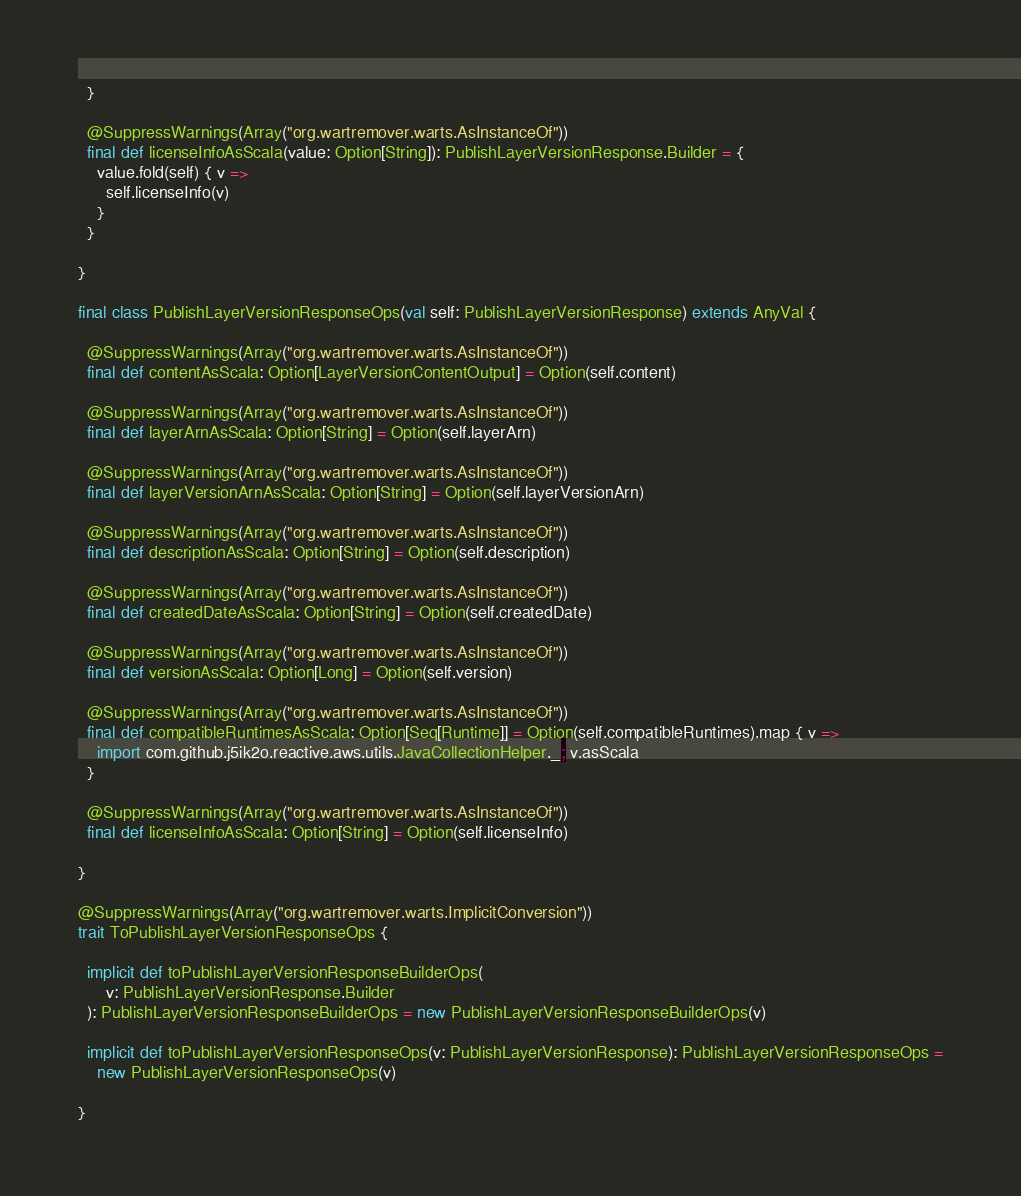Convert code to text. <code><loc_0><loc_0><loc_500><loc_500><_Scala_>  }

  @SuppressWarnings(Array("org.wartremover.warts.AsInstanceOf"))
  final def licenseInfoAsScala(value: Option[String]): PublishLayerVersionResponse.Builder = {
    value.fold(self) { v =>
      self.licenseInfo(v)
    }
  }

}

final class PublishLayerVersionResponseOps(val self: PublishLayerVersionResponse) extends AnyVal {

  @SuppressWarnings(Array("org.wartremover.warts.AsInstanceOf"))
  final def contentAsScala: Option[LayerVersionContentOutput] = Option(self.content)

  @SuppressWarnings(Array("org.wartremover.warts.AsInstanceOf"))
  final def layerArnAsScala: Option[String] = Option(self.layerArn)

  @SuppressWarnings(Array("org.wartremover.warts.AsInstanceOf"))
  final def layerVersionArnAsScala: Option[String] = Option(self.layerVersionArn)

  @SuppressWarnings(Array("org.wartremover.warts.AsInstanceOf"))
  final def descriptionAsScala: Option[String] = Option(self.description)

  @SuppressWarnings(Array("org.wartremover.warts.AsInstanceOf"))
  final def createdDateAsScala: Option[String] = Option(self.createdDate)

  @SuppressWarnings(Array("org.wartremover.warts.AsInstanceOf"))
  final def versionAsScala: Option[Long] = Option(self.version)

  @SuppressWarnings(Array("org.wartremover.warts.AsInstanceOf"))
  final def compatibleRuntimesAsScala: Option[Seq[Runtime]] = Option(self.compatibleRuntimes).map { v =>
    import com.github.j5ik2o.reactive.aws.utils.JavaCollectionHelper._; v.asScala
  }

  @SuppressWarnings(Array("org.wartremover.warts.AsInstanceOf"))
  final def licenseInfoAsScala: Option[String] = Option(self.licenseInfo)

}

@SuppressWarnings(Array("org.wartremover.warts.ImplicitConversion"))
trait ToPublishLayerVersionResponseOps {

  implicit def toPublishLayerVersionResponseBuilderOps(
      v: PublishLayerVersionResponse.Builder
  ): PublishLayerVersionResponseBuilderOps = new PublishLayerVersionResponseBuilderOps(v)

  implicit def toPublishLayerVersionResponseOps(v: PublishLayerVersionResponse): PublishLayerVersionResponseOps =
    new PublishLayerVersionResponseOps(v)

}
</code> 